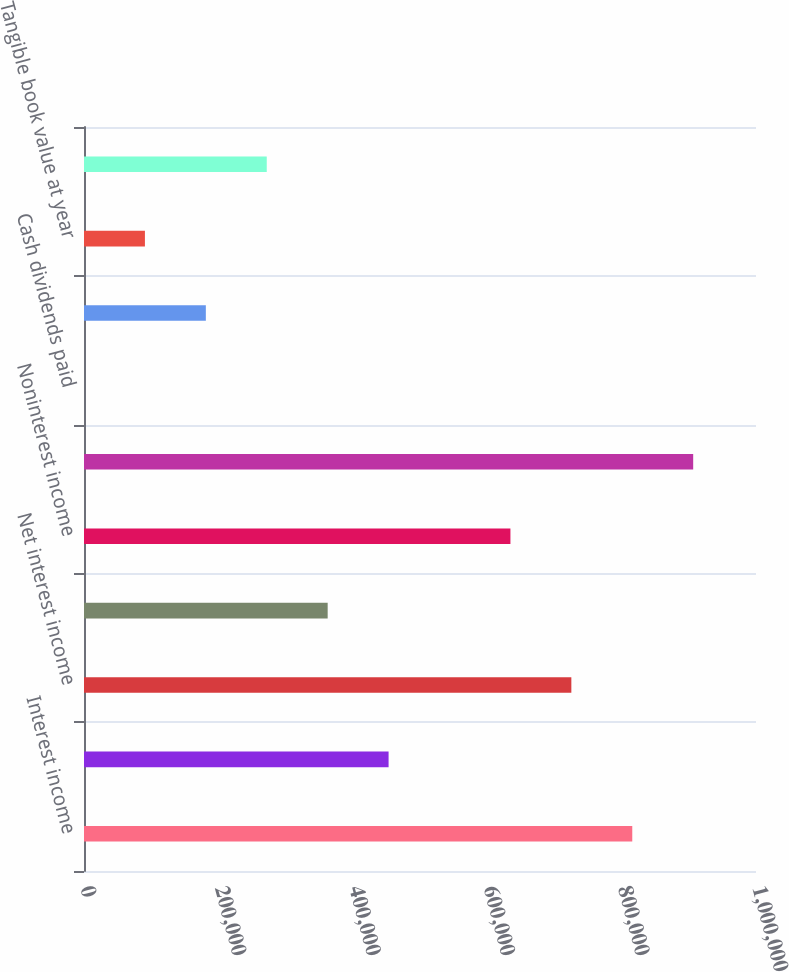<chart> <loc_0><loc_0><loc_500><loc_500><bar_chart><fcel>Interest income<fcel>Interest expense<fcel>Net interest income<fcel>Provision (credit) for loan<fcel>Noninterest income<fcel>Noninterest expense<fcel>Cash dividends paid<fcel>Book value at year end<fcel>Tangible book value at year<fcel>Market price at year end<nl><fcel>815872<fcel>453262<fcel>725219<fcel>362610<fcel>634567<fcel>906524<fcel>0.21<fcel>181305<fcel>90652.6<fcel>271957<nl></chart> 